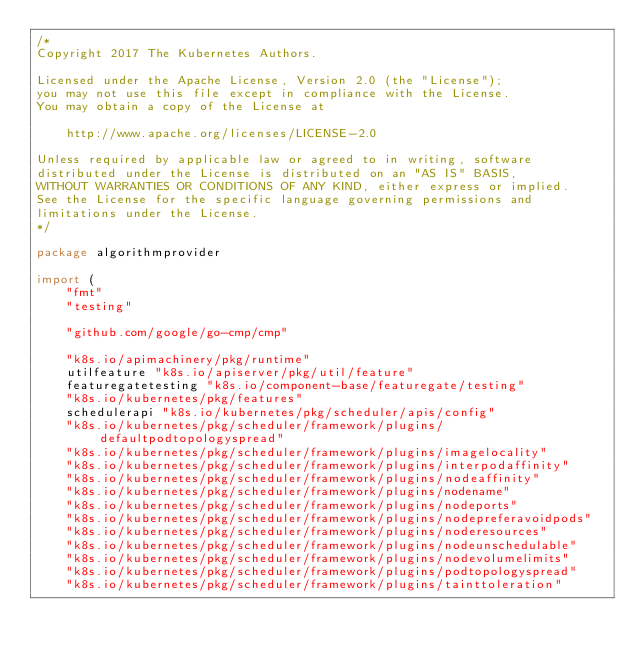<code> <loc_0><loc_0><loc_500><loc_500><_Go_>/*
Copyright 2017 The Kubernetes Authors.

Licensed under the Apache License, Version 2.0 (the "License");
you may not use this file except in compliance with the License.
You may obtain a copy of the License at

    http://www.apache.org/licenses/LICENSE-2.0

Unless required by applicable law or agreed to in writing, software
distributed under the License is distributed on an "AS IS" BASIS,
WITHOUT WARRANTIES OR CONDITIONS OF ANY KIND, either express or implied.
See the License for the specific language governing permissions and
limitations under the License.
*/

package algorithmprovider

import (
	"fmt"
	"testing"

	"github.com/google/go-cmp/cmp"

	"k8s.io/apimachinery/pkg/runtime"
	utilfeature "k8s.io/apiserver/pkg/util/feature"
	featuregatetesting "k8s.io/component-base/featuregate/testing"
	"k8s.io/kubernetes/pkg/features"
	schedulerapi "k8s.io/kubernetes/pkg/scheduler/apis/config"
	"k8s.io/kubernetes/pkg/scheduler/framework/plugins/defaultpodtopologyspread"
	"k8s.io/kubernetes/pkg/scheduler/framework/plugins/imagelocality"
	"k8s.io/kubernetes/pkg/scheduler/framework/plugins/interpodaffinity"
	"k8s.io/kubernetes/pkg/scheduler/framework/plugins/nodeaffinity"
	"k8s.io/kubernetes/pkg/scheduler/framework/plugins/nodename"
	"k8s.io/kubernetes/pkg/scheduler/framework/plugins/nodeports"
	"k8s.io/kubernetes/pkg/scheduler/framework/plugins/nodepreferavoidpods"
	"k8s.io/kubernetes/pkg/scheduler/framework/plugins/noderesources"
	"k8s.io/kubernetes/pkg/scheduler/framework/plugins/nodeunschedulable"
	"k8s.io/kubernetes/pkg/scheduler/framework/plugins/nodevolumelimits"
	"k8s.io/kubernetes/pkg/scheduler/framework/plugins/podtopologyspread"
	"k8s.io/kubernetes/pkg/scheduler/framework/plugins/tainttoleration"</code> 